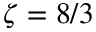Convert formula to latex. <formula><loc_0><loc_0><loc_500><loc_500>\zeta = 8 / 3</formula> 